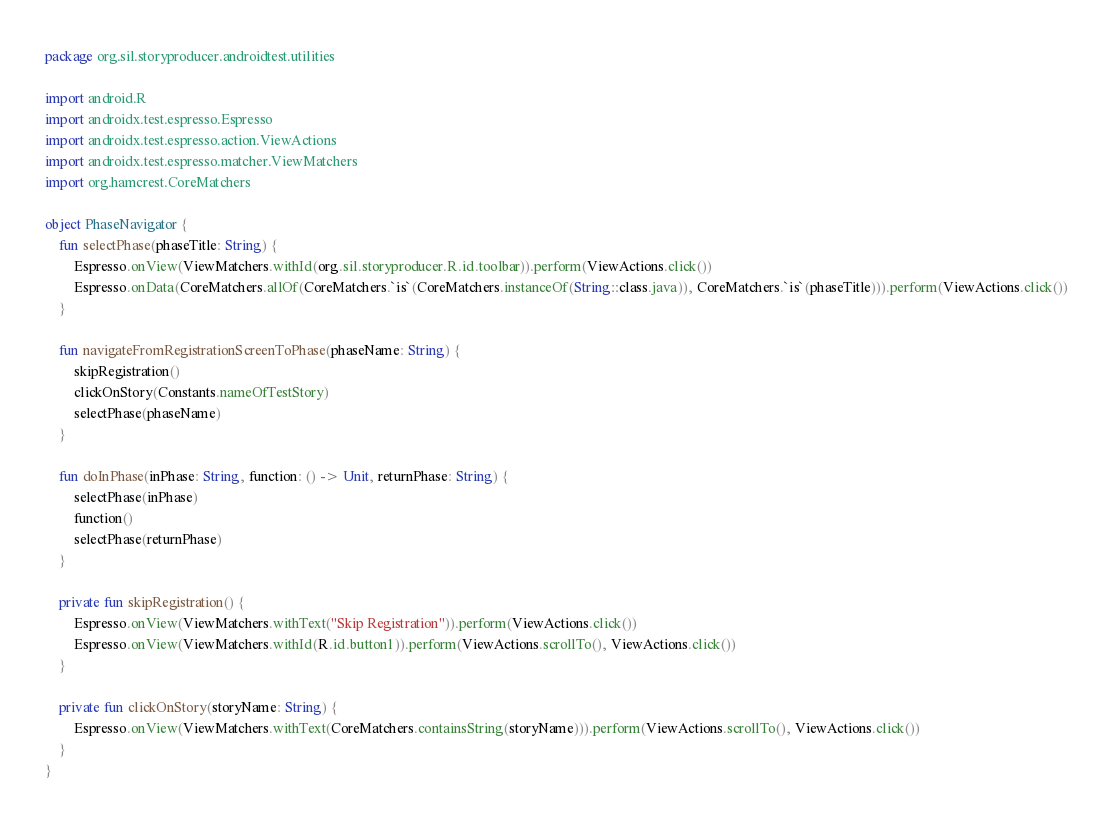Convert code to text. <code><loc_0><loc_0><loc_500><loc_500><_Kotlin_>package org.sil.storyproducer.androidtest.utilities

import android.R
import androidx.test.espresso.Espresso
import androidx.test.espresso.action.ViewActions
import androidx.test.espresso.matcher.ViewMatchers
import org.hamcrest.CoreMatchers

object PhaseNavigator {
    fun selectPhase(phaseTitle: String) {
        Espresso.onView(ViewMatchers.withId(org.sil.storyproducer.R.id.toolbar)).perform(ViewActions.click())
        Espresso.onData(CoreMatchers.allOf(CoreMatchers.`is`(CoreMatchers.instanceOf(String::class.java)), CoreMatchers.`is`(phaseTitle))).perform(ViewActions.click())
    }

    fun navigateFromRegistrationScreenToPhase(phaseName: String) {
        skipRegistration()
        clickOnStory(Constants.nameOfTestStory)
        selectPhase(phaseName)
    }

    fun doInPhase(inPhase: String, function: () -> Unit, returnPhase: String) {
        selectPhase(inPhase)
        function()
        selectPhase(returnPhase)
    }

    private fun skipRegistration() {
        Espresso.onView(ViewMatchers.withText("Skip Registration")).perform(ViewActions.click())
        Espresso.onView(ViewMatchers.withId(R.id.button1)).perform(ViewActions.scrollTo(), ViewActions.click())
    }

    private fun clickOnStory(storyName: String) {
        Espresso.onView(ViewMatchers.withText(CoreMatchers.containsString(storyName))).perform(ViewActions.scrollTo(), ViewActions.click())
    }
}</code> 